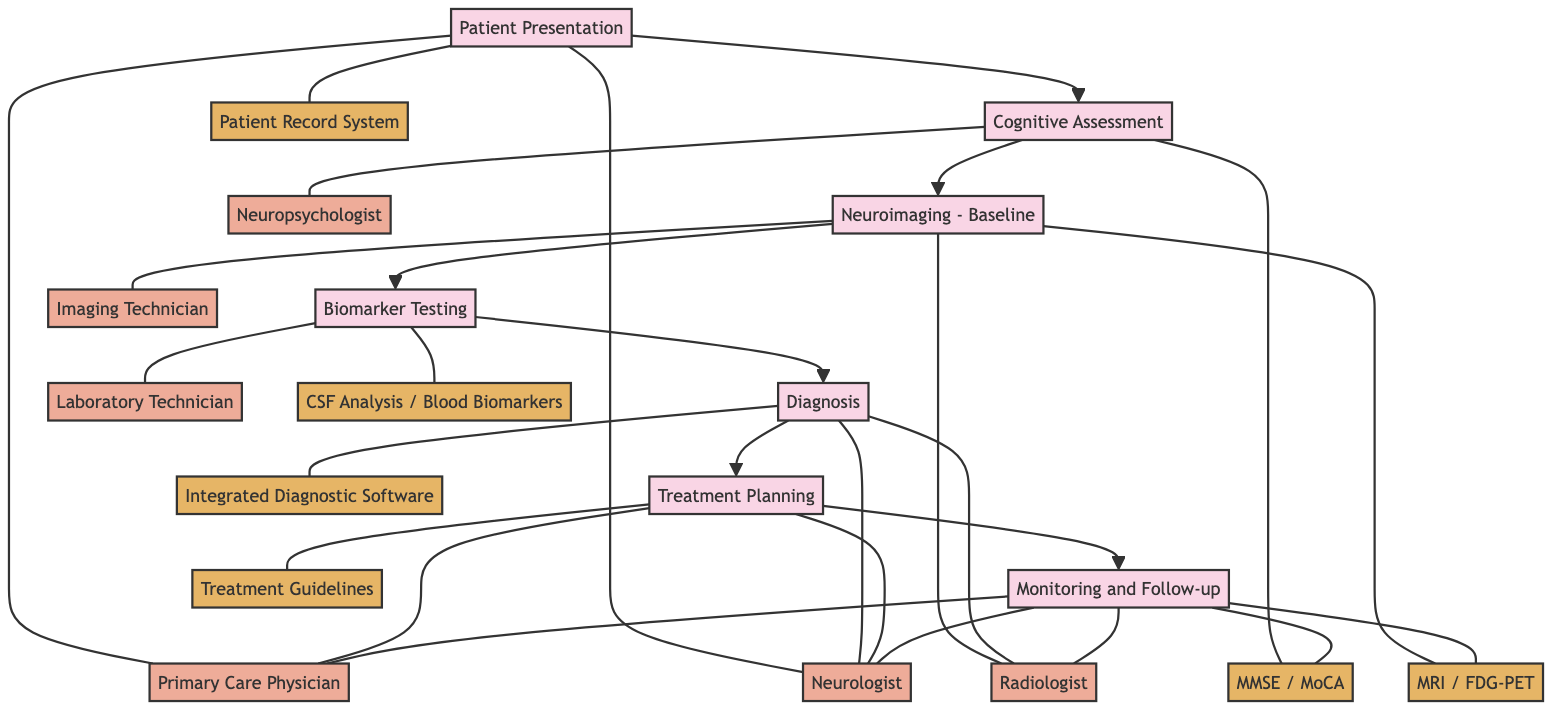What is the first step in the pathway? The diagram indicates that the first step in the pathway is "Patient Presentation." This is clearly labeled at the beginning of the flowchart and leads to the next step.
Answer: Patient Presentation How many actors are involved in the Diagnosis step? In the Diagnosis step, there are two actors mentioned: "Neurologist" and "Radiologist." This can be seen in the flow from the Diagnosis node where these actors are connected.
Answer: 2 What tools are used during Cognitive Assessment? The diagram shows that the tools used during the Cognitive Assessment step are "MMSE (Mini-Mental State Examination)" and "MoCA (Montreal Cognitive Assessment)." These tools are listed under the Cognitive Assessment node.
Answer: MMSE (Mini-Mental State Examination), MoCA (Montreal Cognitive Assessment) Which actor does not participate in the Monitoring and Follow-up step? The diagram indicates that the "Neuropsychologist" does not participate in the Monitoring and Follow-up step, as they are not listed under that node's actors.
Answer: Neuropsychologist What is the last step in the pathway? The last step in the pathway, as shown in the diagram, is "Monitoring and Follow-up," which can be found at the end of the flowchart sequence.
Answer: Monitoring and Follow-up Which step includes the use of Integrated Diagnostic Software? The diagram shows that the step "Diagnosis" includes the use of "Integrated Diagnostic Software" as a tool. This can be observed in the connections branching out of the Diagnosis node.
Answer: Diagnosis How many steps are there in the Clinical Pathway? The diagram represents a total of seven steps in the Clinical Pathway, as indicated by the number of nodes present in the flowchart.
Answer: 7 Which tools are utilized for Neuroimaging - Baseline? The tools identified for the Neuroimaging - Baseline step are "MRI (Magnetic Resonance Imaging)" and "FDG-PET (Fluorodeoxyglucose-Positron Emission Tomography)," listed under that step in the diagram.
Answer: MRI (Magnetic Resonance Imaging), FDG-PET (Fluorodeoxyglucose-Positron Emission Tomography) 